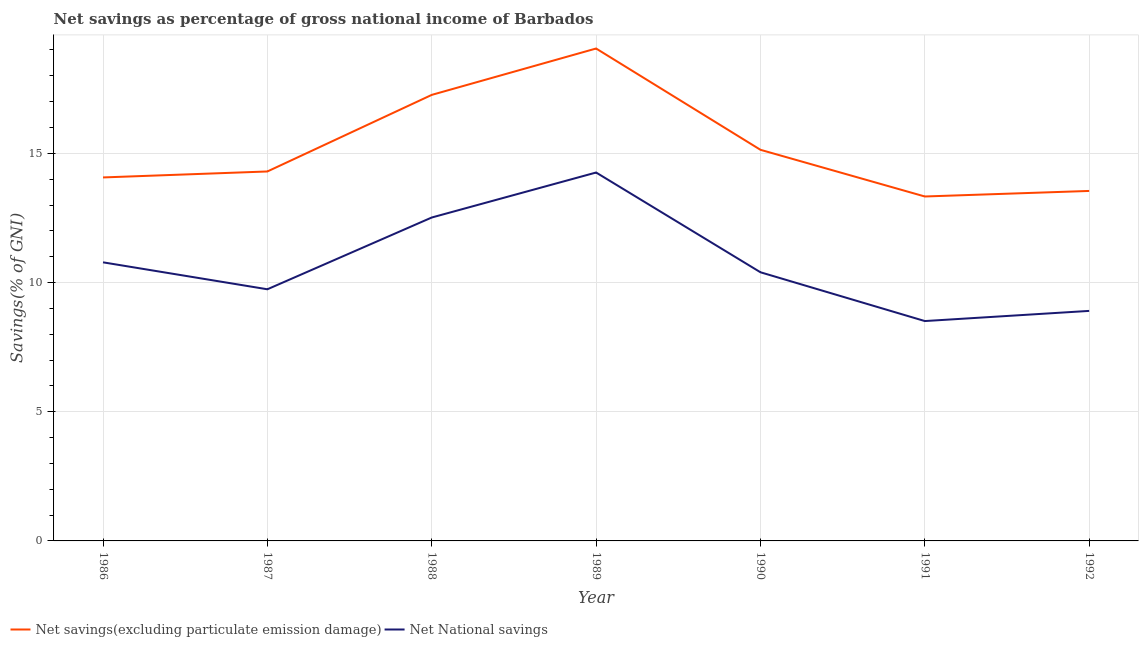How many different coloured lines are there?
Your response must be concise. 2. Does the line corresponding to net national savings intersect with the line corresponding to net savings(excluding particulate emission damage)?
Keep it short and to the point. No. What is the net savings(excluding particulate emission damage) in 1987?
Provide a short and direct response. 14.3. Across all years, what is the maximum net savings(excluding particulate emission damage)?
Provide a succinct answer. 19.06. Across all years, what is the minimum net national savings?
Make the answer very short. 8.51. In which year was the net savings(excluding particulate emission damage) maximum?
Give a very brief answer. 1989. In which year was the net national savings minimum?
Your answer should be very brief. 1991. What is the total net national savings in the graph?
Your response must be concise. 75.1. What is the difference between the net national savings in 1986 and that in 1989?
Ensure brevity in your answer.  -3.48. What is the difference between the net national savings in 1986 and the net savings(excluding particulate emission damage) in 1988?
Offer a terse response. -6.48. What is the average net national savings per year?
Your response must be concise. 10.73. In the year 1990, what is the difference between the net savings(excluding particulate emission damage) and net national savings?
Keep it short and to the point. 4.74. In how many years, is the net national savings greater than 15 %?
Your response must be concise. 0. What is the ratio of the net national savings in 1986 to that in 1992?
Give a very brief answer. 1.21. Is the difference between the net savings(excluding particulate emission damage) in 1987 and 1991 greater than the difference between the net national savings in 1987 and 1991?
Your response must be concise. No. What is the difference between the highest and the second highest net savings(excluding particulate emission damage)?
Ensure brevity in your answer.  1.8. What is the difference between the highest and the lowest net savings(excluding particulate emission damage)?
Your answer should be compact. 5.73. Is the sum of the net national savings in 1986 and 1988 greater than the maximum net savings(excluding particulate emission damage) across all years?
Your answer should be very brief. Yes. Does the net national savings monotonically increase over the years?
Give a very brief answer. No. Is the net national savings strictly greater than the net savings(excluding particulate emission damage) over the years?
Provide a succinct answer. No. Is the net savings(excluding particulate emission damage) strictly less than the net national savings over the years?
Offer a terse response. No. What is the difference between two consecutive major ticks on the Y-axis?
Your response must be concise. 5. Are the values on the major ticks of Y-axis written in scientific E-notation?
Your answer should be compact. No. Does the graph contain grids?
Provide a short and direct response. Yes. Where does the legend appear in the graph?
Your answer should be very brief. Bottom left. How many legend labels are there?
Offer a very short reply. 2. What is the title of the graph?
Provide a succinct answer. Net savings as percentage of gross national income of Barbados. What is the label or title of the X-axis?
Keep it short and to the point. Year. What is the label or title of the Y-axis?
Make the answer very short. Savings(% of GNI). What is the Savings(% of GNI) of Net savings(excluding particulate emission damage) in 1986?
Provide a succinct answer. 14.07. What is the Savings(% of GNI) of Net National savings in 1986?
Your response must be concise. 10.78. What is the Savings(% of GNI) in Net savings(excluding particulate emission damage) in 1987?
Your response must be concise. 14.3. What is the Savings(% of GNI) of Net National savings in 1987?
Offer a terse response. 9.74. What is the Savings(% of GNI) in Net savings(excluding particulate emission damage) in 1988?
Give a very brief answer. 17.26. What is the Savings(% of GNI) in Net National savings in 1988?
Ensure brevity in your answer.  12.52. What is the Savings(% of GNI) of Net savings(excluding particulate emission damage) in 1989?
Offer a very short reply. 19.06. What is the Savings(% of GNI) of Net National savings in 1989?
Your answer should be compact. 14.26. What is the Savings(% of GNI) of Net savings(excluding particulate emission damage) in 1990?
Your answer should be very brief. 15.14. What is the Savings(% of GNI) of Net National savings in 1990?
Provide a succinct answer. 10.4. What is the Savings(% of GNI) of Net savings(excluding particulate emission damage) in 1991?
Make the answer very short. 13.33. What is the Savings(% of GNI) in Net National savings in 1991?
Your answer should be compact. 8.51. What is the Savings(% of GNI) in Net savings(excluding particulate emission damage) in 1992?
Make the answer very short. 13.54. What is the Savings(% of GNI) in Net National savings in 1992?
Make the answer very short. 8.9. Across all years, what is the maximum Savings(% of GNI) of Net savings(excluding particulate emission damage)?
Give a very brief answer. 19.06. Across all years, what is the maximum Savings(% of GNI) of Net National savings?
Offer a very short reply. 14.26. Across all years, what is the minimum Savings(% of GNI) of Net savings(excluding particulate emission damage)?
Your answer should be compact. 13.33. Across all years, what is the minimum Savings(% of GNI) of Net National savings?
Your answer should be compact. 8.51. What is the total Savings(% of GNI) in Net savings(excluding particulate emission damage) in the graph?
Offer a very short reply. 106.69. What is the total Savings(% of GNI) of Net National savings in the graph?
Your answer should be compact. 75.1. What is the difference between the Savings(% of GNI) of Net savings(excluding particulate emission damage) in 1986 and that in 1987?
Your answer should be compact. -0.23. What is the difference between the Savings(% of GNI) in Net National savings in 1986 and that in 1987?
Provide a succinct answer. 1.04. What is the difference between the Savings(% of GNI) of Net savings(excluding particulate emission damage) in 1986 and that in 1988?
Give a very brief answer. -3.19. What is the difference between the Savings(% of GNI) of Net National savings in 1986 and that in 1988?
Your response must be concise. -1.73. What is the difference between the Savings(% of GNI) in Net savings(excluding particulate emission damage) in 1986 and that in 1989?
Keep it short and to the point. -4.99. What is the difference between the Savings(% of GNI) in Net National savings in 1986 and that in 1989?
Offer a terse response. -3.48. What is the difference between the Savings(% of GNI) in Net savings(excluding particulate emission damage) in 1986 and that in 1990?
Make the answer very short. -1.07. What is the difference between the Savings(% of GNI) of Net National savings in 1986 and that in 1990?
Give a very brief answer. 0.38. What is the difference between the Savings(% of GNI) in Net savings(excluding particulate emission damage) in 1986 and that in 1991?
Your response must be concise. 0.74. What is the difference between the Savings(% of GNI) in Net National savings in 1986 and that in 1991?
Your response must be concise. 2.27. What is the difference between the Savings(% of GNI) in Net savings(excluding particulate emission damage) in 1986 and that in 1992?
Make the answer very short. 0.52. What is the difference between the Savings(% of GNI) of Net National savings in 1986 and that in 1992?
Provide a short and direct response. 1.88. What is the difference between the Savings(% of GNI) in Net savings(excluding particulate emission damage) in 1987 and that in 1988?
Offer a very short reply. -2.96. What is the difference between the Savings(% of GNI) of Net National savings in 1987 and that in 1988?
Keep it short and to the point. -2.78. What is the difference between the Savings(% of GNI) of Net savings(excluding particulate emission damage) in 1987 and that in 1989?
Offer a terse response. -4.76. What is the difference between the Savings(% of GNI) of Net National savings in 1987 and that in 1989?
Ensure brevity in your answer.  -4.52. What is the difference between the Savings(% of GNI) of Net savings(excluding particulate emission damage) in 1987 and that in 1990?
Your response must be concise. -0.84. What is the difference between the Savings(% of GNI) of Net National savings in 1987 and that in 1990?
Give a very brief answer. -0.66. What is the difference between the Savings(% of GNI) of Net savings(excluding particulate emission damage) in 1987 and that in 1991?
Your answer should be very brief. 0.97. What is the difference between the Savings(% of GNI) in Net National savings in 1987 and that in 1991?
Your response must be concise. 1.23. What is the difference between the Savings(% of GNI) in Net savings(excluding particulate emission damage) in 1987 and that in 1992?
Ensure brevity in your answer.  0.75. What is the difference between the Savings(% of GNI) of Net National savings in 1987 and that in 1992?
Provide a succinct answer. 0.84. What is the difference between the Savings(% of GNI) of Net savings(excluding particulate emission damage) in 1988 and that in 1989?
Offer a very short reply. -1.8. What is the difference between the Savings(% of GNI) of Net National savings in 1988 and that in 1989?
Your answer should be very brief. -1.74. What is the difference between the Savings(% of GNI) of Net savings(excluding particulate emission damage) in 1988 and that in 1990?
Provide a short and direct response. 2.12. What is the difference between the Savings(% of GNI) in Net National savings in 1988 and that in 1990?
Your answer should be very brief. 2.12. What is the difference between the Savings(% of GNI) of Net savings(excluding particulate emission damage) in 1988 and that in 1991?
Your answer should be very brief. 3.93. What is the difference between the Savings(% of GNI) of Net National savings in 1988 and that in 1991?
Make the answer very short. 4.01. What is the difference between the Savings(% of GNI) of Net savings(excluding particulate emission damage) in 1988 and that in 1992?
Give a very brief answer. 3.72. What is the difference between the Savings(% of GNI) in Net National savings in 1988 and that in 1992?
Keep it short and to the point. 3.61. What is the difference between the Savings(% of GNI) of Net savings(excluding particulate emission damage) in 1989 and that in 1990?
Your answer should be compact. 3.92. What is the difference between the Savings(% of GNI) of Net National savings in 1989 and that in 1990?
Your answer should be very brief. 3.86. What is the difference between the Savings(% of GNI) of Net savings(excluding particulate emission damage) in 1989 and that in 1991?
Provide a succinct answer. 5.73. What is the difference between the Savings(% of GNI) of Net National savings in 1989 and that in 1991?
Offer a terse response. 5.75. What is the difference between the Savings(% of GNI) in Net savings(excluding particulate emission damage) in 1989 and that in 1992?
Offer a terse response. 5.51. What is the difference between the Savings(% of GNI) in Net National savings in 1989 and that in 1992?
Provide a short and direct response. 5.36. What is the difference between the Savings(% of GNI) of Net savings(excluding particulate emission damage) in 1990 and that in 1991?
Offer a terse response. 1.81. What is the difference between the Savings(% of GNI) in Net National savings in 1990 and that in 1991?
Keep it short and to the point. 1.89. What is the difference between the Savings(% of GNI) in Net savings(excluding particulate emission damage) in 1990 and that in 1992?
Give a very brief answer. 1.59. What is the difference between the Savings(% of GNI) of Net National savings in 1990 and that in 1992?
Ensure brevity in your answer.  1.49. What is the difference between the Savings(% of GNI) in Net savings(excluding particulate emission damage) in 1991 and that in 1992?
Keep it short and to the point. -0.21. What is the difference between the Savings(% of GNI) in Net National savings in 1991 and that in 1992?
Offer a terse response. -0.39. What is the difference between the Savings(% of GNI) in Net savings(excluding particulate emission damage) in 1986 and the Savings(% of GNI) in Net National savings in 1987?
Offer a terse response. 4.33. What is the difference between the Savings(% of GNI) of Net savings(excluding particulate emission damage) in 1986 and the Savings(% of GNI) of Net National savings in 1988?
Ensure brevity in your answer.  1.55. What is the difference between the Savings(% of GNI) of Net savings(excluding particulate emission damage) in 1986 and the Savings(% of GNI) of Net National savings in 1989?
Provide a succinct answer. -0.19. What is the difference between the Savings(% of GNI) of Net savings(excluding particulate emission damage) in 1986 and the Savings(% of GNI) of Net National savings in 1990?
Give a very brief answer. 3.67. What is the difference between the Savings(% of GNI) in Net savings(excluding particulate emission damage) in 1986 and the Savings(% of GNI) in Net National savings in 1991?
Your answer should be compact. 5.56. What is the difference between the Savings(% of GNI) in Net savings(excluding particulate emission damage) in 1986 and the Savings(% of GNI) in Net National savings in 1992?
Keep it short and to the point. 5.17. What is the difference between the Savings(% of GNI) in Net savings(excluding particulate emission damage) in 1987 and the Savings(% of GNI) in Net National savings in 1988?
Give a very brief answer. 1.78. What is the difference between the Savings(% of GNI) in Net savings(excluding particulate emission damage) in 1987 and the Savings(% of GNI) in Net National savings in 1989?
Offer a terse response. 0.04. What is the difference between the Savings(% of GNI) of Net savings(excluding particulate emission damage) in 1987 and the Savings(% of GNI) of Net National savings in 1990?
Ensure brevity in your answer.  3.9. What is the difference between the Savings(% of GNI) of Net savings(excluding particulate emission damage) in 1987 and the Savings(% of GNI) of Net National savings in 1991?
Give a very brief answer. 5.79. What is the difference between the Savings(% of GNI) of Net savings(excluding particulate emission damage) in 1987 and the Savings(% of GNI) of Net National savings in 1992?
Your answer should be very brief. 5.4. What is the difference between the Savings(% of GNI) in Net savings(excluding particulate emission damage) in 1988 and the Savings(% of GNI) in Net National savings in 1989?
Your answer should be very brief. 3. What is the difference between the Savings(% of GNI) of Net savings(excluding particulate emission damage) in 1988 and the Savings(% of GNI) of Net National savings in 1990?
Your response must be concise. 6.86. What is the difference between the Savings(% of GNI) of Net savings(excluding particulate emission damage) in 1988 and the Savings(% of GNI) of Net National savings in 1991?
Give a very brief answer. 8.75. What is the difference between the Savings(% of GNI) of Net savings(excluding particulate emission damage) in 1988 and the Savings(% of GNI) of Net National savings in 1992?
Provide a short and direct response. 8.36. What is the difference between the Savings(% of GNI) of Net savings(excluding particulate emission damage) in 1989 and the Savings(% of GNI) of Net National savings in 1990?
Your answer should be very brief. 8.66. What is the difference between the Savings(% of GNI) of Net savings(excluding particulate emission damage) in 1989 and the Savings(% of GNI) of Net National savings in 1991?
Your answer should be compact. 10.55. What is the difference between the Savings(% of GNI) in Net savings(excluding particulate emission damage) in 1989 and the Savings(% of GNI) in Net National savings in 1992?
Keep it short and to the point. 10.15. What is the difference between the Savings(% of GNI) in Net savings(excluding particulate emission damage) in 1990 and the Savings(% of GNI) in Net National savings in 1991?
Your response must be concise. 6.63. What is the difference between the Savings(% of GNI) of Net savings(excluding particulate emission damage) in 1990 and the Savings(% of GNI) of Net National savings in 1992?
Give a very brief answer. 6.23. What is the difference between the Savings(% of GNI) in Net savings(excluding particulate emission damage) in 1991 and the Savings(% of GNI) in Net National savings in 1992?
Your response must be concise. 4.43. What is the average Savings(% of GNI) in Net savings(excluding particulate emission damage) per year?
Offer a very short reply. 15.24. What is the average Savings(% of GNI) of Net National savings per year?
Make the answer very short. 10.73. In the year 1986, what is the difference between the Savings(% of GNI) of Net savings(excluding particulate emission damage) and Savings(% of GNI) of Net National savings?
Give a very brief answer. 3.29. In the year 1987, what is the difference between the Savings(% of GNI) of Net savings(excluding particulate emission damage) and Savings(% of GNI) of Net National savings?
Provide a succinct answer. 4.56. In the year 1988, what is the difference between the Savings(% of GNI) of Net savings(excluding particulate emission damage) and Savings(% of GNI) of Net National savings?
Provide a succinct answer. 4.75. In the year 1989, what is the difference between the Savings(% of GNI) in Net savings(excluding particulate emission damage) and Savings(% of GNI) in Net National savings?
Ensure brevity in your answer.  4.8. In the year 1990, what is the difference between the Savings(% of GNI) in Net savings(excluding particulate emission damage) and Savings(% of GNI) in Net National savings?
Offer a very short reply. 4.74. In the year 1991, what is the difference between the Savings(% of GNI) of Net savings(excluding particulate emission damage) and Savings(% of GNI) of Net National savings?
Give a very brief answer. 4.82. In the year 1992, what is the difference between the Savings(% of GNI) in Net savings(excluding particulate emission damage) and Savings(% of GNI) in Net National savings?
Provide a short and direct response. 4.64. What is the ratio of the Savings(% of GNI) of Net savings(excluding particulate emission damage) in 1986 to that in 1987?
Ensure brevity in your answer.  0.98. What is the ratio of the Savings(% of GNI) of Net National savings in 1986 to that in 1987?
Keep it short and to the point. 1.11. What is the ratio of the Savings(% of GNI) in Net savings(excluding particulate emission damage) in 1986 to that in 1988?
Ensure brevity in your answer.  0.81. What is the ratio of the Savings(% of GNI) of Net National savings in 1986 to that in 1988?
Give a very brief answer. 0.86. What is the ratio of the Savings(% of GNI) of Net savings(excluding particulate emission damage) in 1986 to that in 1989?
Offer a very short reply. 0.74. What is the ratio of the Savings(% of GNI) in Net National savings in 1986 to that in 1989?
Keep it short and to the point. 0.76. What is the ratio of the Savings(% of GNI) of Net savings(excluding particulate emission damage) in 1986 to that in 1990?
Give a very brief answer. 0.93. What is the ratio of the Savings(% of GNI) in Net National savings in 1986 to that in 1990?
Your answer should be very brief. 1.04. What is the ratio of the Savings(% of GNI) in Net savings(excluding particulate emission damage) in 1986 to that in 1991?
Provide a succinct answer. 1.06. What is the ratio of the Savings(% of GNI) in Net National savings in 1986 to that in 1991?
Keep it short and to the point. 1.27. What is the ratio of the Savings(% of GNI) in Net savings(excluding particulate emission damage) in 1986 to that in 1992?
Provide a short and direct response. 1.04. What is the ratio of the Savings(% of GNI) of Net National savings in 1986 to that in 1992?
Keep it short and to the point. 1.21. What is the ratio of the Savings(% of GNI) in Net savings(excluding particulate emission damage) in 1987 to that in 1988?
Ensure brevity in your answer.  0.83. What is the ratio of the Savings(% of GNI) of Net National savings in 1987 to that in 1988?
Your answer should be compact. 0.78. What is the ratio of the Savings(% of GNI) of Net savings(excluding particulate emission damage) in 1987 to that in 1989?
Your response must be concise. 0.75. What is the ratio of the Savings(% of GNI) in Net National savings in 1987 to that in 1989?
Your response must be concise. 0.68. What is the ratio of the Savings(% of GNI) of Net savings(excluding particulate emission damage) in 1987 to that in 1990?
Give a very brief answer. 0.94. What is the ratio of the Savings(% of GNI) in Net National savings in 1987 to that in 1990?
Your answer should be very brief. 0.94. What is the ratio of the Savings(% of GNI) in Net savings(excluding particulate emission damage) in 1987 to that in 1991?
Ensure brevity in your answer.  1.07. What is the ratio of the Savings(% of GNI) of Net National savings in 1987 to that in 1991?
Make the answer very short. 1.14. What is the ratio of the Savings(% of GNI) of Net savings(excluding particulate emission damage) in 1987 to that in 1992?
Give a very brief answer. 1.06. What is the ratio of the Savings(% of GNI) in Net National savings in 1987 to that in 1992?
Offer a very short reply. 1.09. What is the ratio of the Savings(% of GNI) of Net savings(excluding particulate emission damage) in 1988 to that in 1989?
Provide a short and direct response. 0.91. What is the ratio of the Savings(% of GNI) in Net National savings in 1988 to that in 1989?
Your answer should be compact. 0.88. What is the ratio of the Savings(% of GNI) in Net savings(excluding particulate emission damage) in 1988 to that in 1990?
Offer a very short reply. 1.14. What is the ratio of the Savings(% of GNI) of Net National savings in 1988 to that in 1990?
Keep it short and to the point. 1.2. What is the ratio of the Savings(% of GNI) of Net savings(excluding particulate emission damage) in 1988 to that in 1991?
Your response must be concise. 1.29. What is the ratio of the Savings(% of GNI) in Net National savings in 1988 to that in 1991?
Keep it short and to the point. 1.47. What is the ratio of the Savings(% of GNI) of Net savings(excluding particulate emission damage) in 1988 to that in 1992?
Your response must be concise. 1.27. What is the ratio of the Savings(% of GNI) in Net National savings in 1988 to that in 1992?
Provide a short and direct response. 1.41. What is the ratio of the Savings(% of GNI) of Net savings(excluding particulate emission damage) in 1989 to that in 1990?
Give a very brief answer. 1.26. What is the ratio of the Savings(% of GNI) of Net National savings in 1989 to that in 1990?
Your response must be concise. 1.37. What is the ratio of the Savings(% of GNI) of Net savings(excluding particulate emission damage) in 1989 to that in 1991?
Your answer should be very brief. 1.43. What is the ratio of the Savings(% of GNI) of Net National savings in 1989 to that in 1991?
Make the answer very short. 1.68. What is the ratio of the Savings(% of GNI) in Net savings(excluding particulate emission damage) in 1989 to that in 1992?
Ensure brevity in your answer.  1.41. What is the ratio of the Savings(% of GNI) of Net National savings in 1989 to that in 1992?
Your answer should be compact. 1.6. What is the ratio of the Savings(% of GNI) of Net savings(excluding particulate emission damage) in 1990 to that in 1991?
Offer a terse response. 1.14. What is the ratio of the Savings(% of GNI) of Net National savings in 1990 to that in 1991?
Your answer should be very brief. 1.22. What is the ratio of the Savings(% of GNI) of Net savings(excluding particulate emission damage) in 1990 to that in 1992?
Give a very brief answer. 1.12. What is the ratio of the Savings(% of GNI) of Net National savings in 1990 to that in 1992?
Offer a very short reply. 1.17. What is the ratio of the Savings(% of GNI) in Net savings(excluding particulate emission damage) in 1991 to that in 1992?
Keep it short and to the point. 0.98. What is the ratio of the Savings(% of GNI) in Net National savings in 1991 to that in 1992?
Give a very brief answer. 0.96. What is the difference between the highest and the second highest Savings(% of GNI) of Net savings(excluding particulate emission damage)?
Give a very brief answer. 1.8. What is the difference between the highest and the second highest Savings(% of GNI) of Net National savings?
Keep it short and to the point. 1.74. What is the difference between the highest and the lowest Savings(% of GNI) of Net savings(excluding particulate emission damage)?
Make the answer very short. 5.73. What is the difference between the highest and the lowest Savings(% of GNI) of Net National savings?
Your response must be concise. 5.75. 